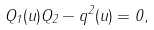Convert formula to latex. <formula><loc_0><loc_0><loc_500><loc_500>Q _ { 1 } ( u ) Q _ { 2 } - q ^ { 2 } ( u ) = 0 ,</formula> 